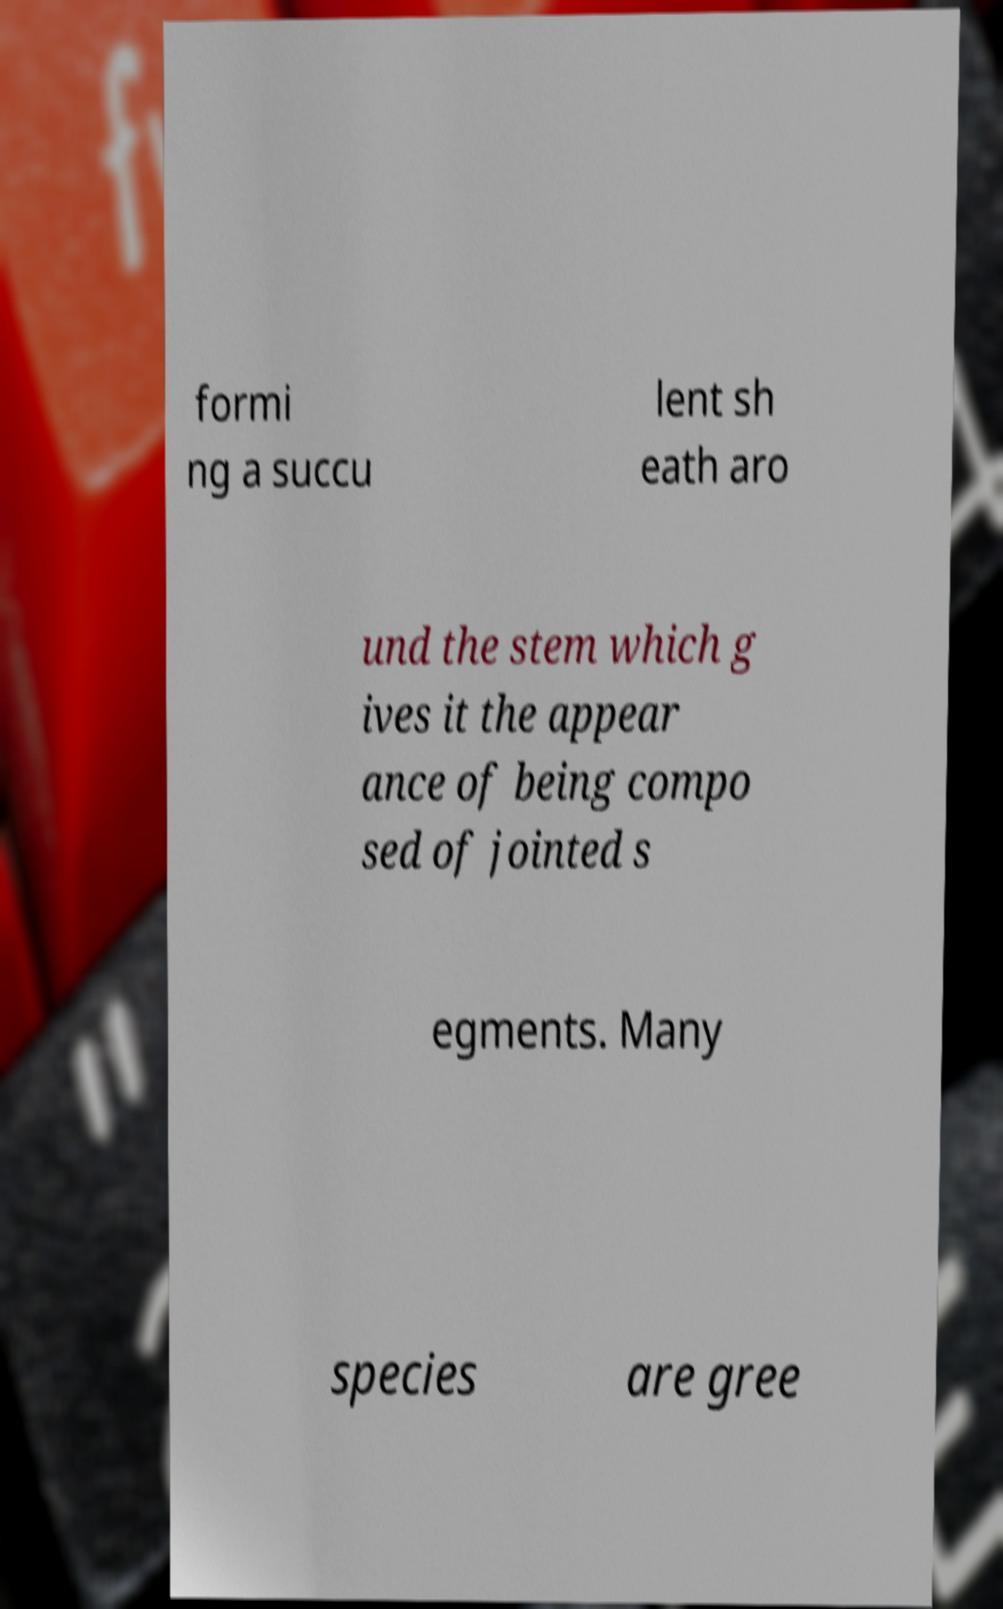Could you extract and type out the text from this image? formi ng a succu lent sh eath aro und the stem which g ives it the appear ance of being compo sed of jointed s egments. Many species are gree 